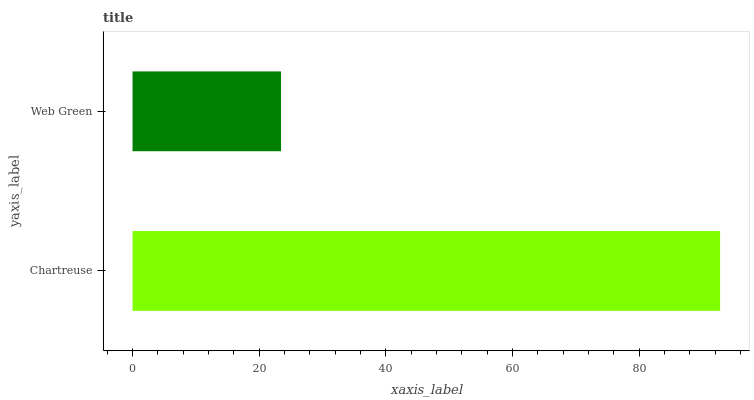Is Web Green the minimum?
Answer yes or no. Yes. Is Chartreuse the maximum?
Answer yes or no. Yes. Is Web Green the maximum?
Answer yes or no. No. Is Chartreuse greater than Web Green?
Answer yes or no. Yes. Is Web Green less than Chartreuse?
Answer yes or no. Yes. Is Web Green greater than Chartreuse?
Answer yes or no. No. Is Chartreuse less than Web Green?
Answer yes or no. No. Is Chartreuse the high median?
Answer yes or no. Yes. Is Web Green the low median?
Answer yes or no. Yes. Is Web Green the high median?
Answer yes or no. No. Is Chartreuse the low median?
Answer yes or no. No. 